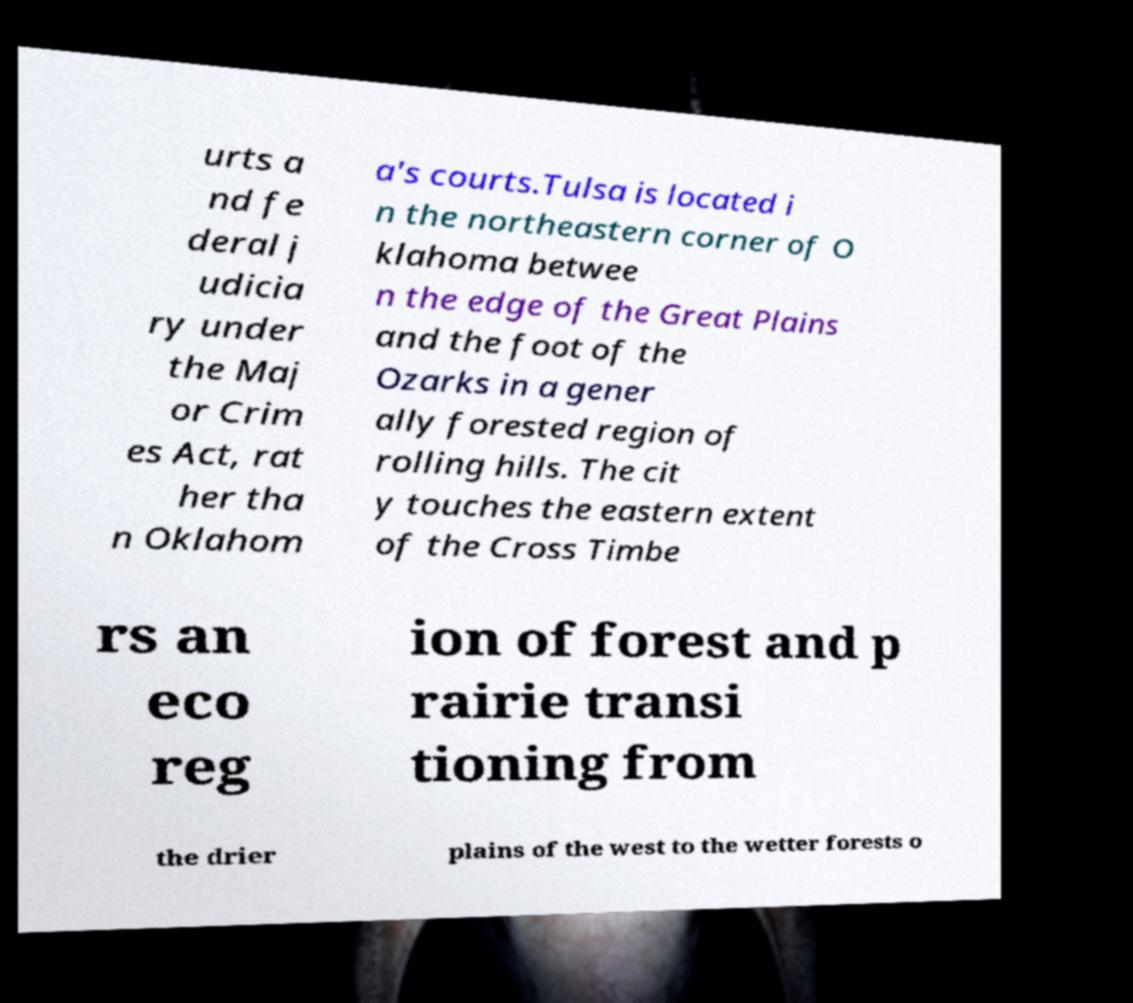Can you read and provide the text displayed in the image?This photo seems to have some interesting text. Can you extract and type it out for me? urts a nd fe deral j udicia ry under the Maj or Crim es Act, rat her tha n Oklahom a's courts.Tulsa is located i n the northeastern corner of O klahoma betwee n the edge of the Great Plains and the foot of the Ozarks in a gener ally forested region of rolling hills. The cit y touches the eastern extent of the Cross Timbe rs an eco reg ion of forest and p rairie transi tioning from the drier plains of the west to the wetter forests o 